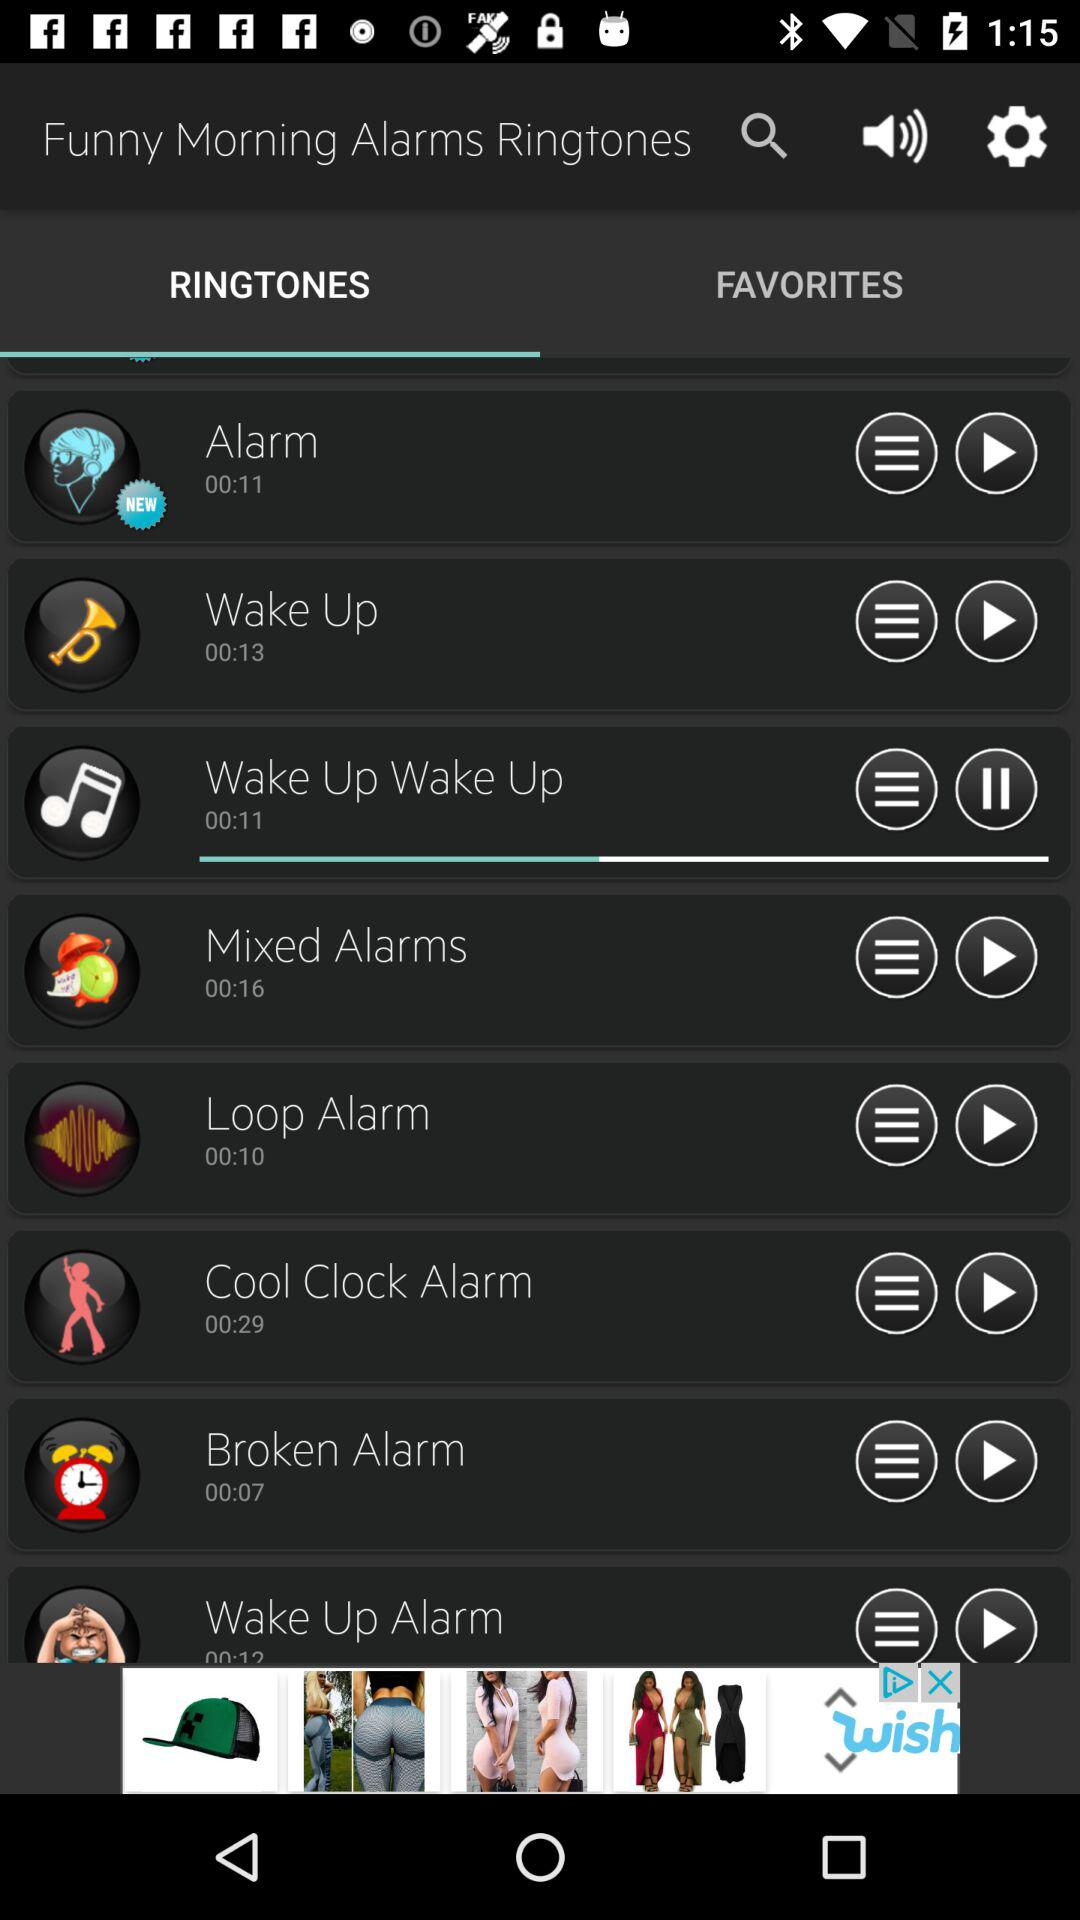What is the duration of the wake-up ringtone? The duration is 00:13 seconds. 